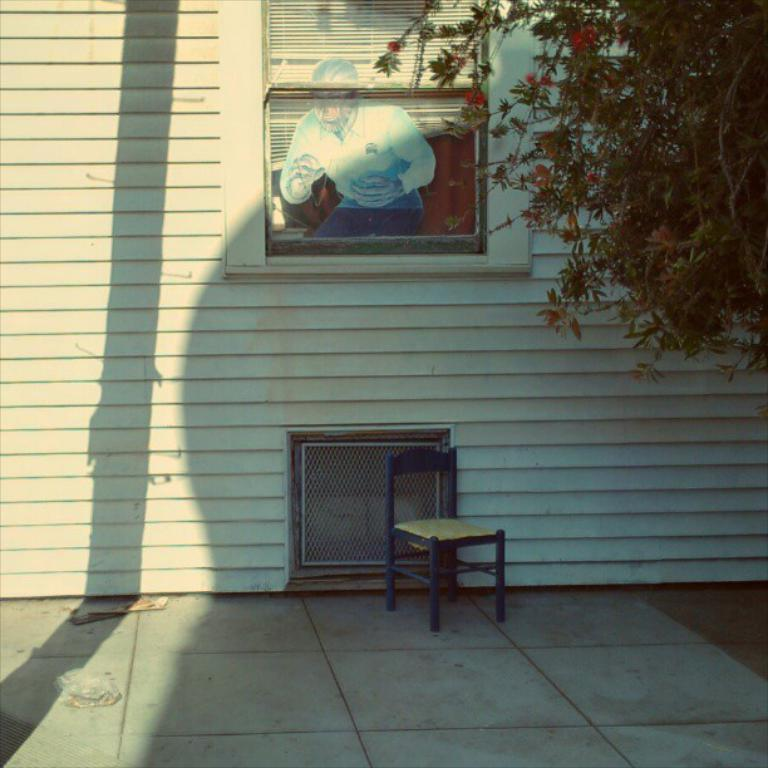What is on the wall in the image? There is a wall with windows in the image, and there is also a sticker on the wall. What can be seen outside the windows in the image? The ground is visible in the image, and there are objects on the ground. What type of furniture is in the image? There is a chair in the image. What is on the right side of the image? There is a tree on the right side of the image. How many boats are docked in the cellar in the image? There are no boats or cellars present in the image. How many beds are visible in the image? There are no beds visible in the image. 